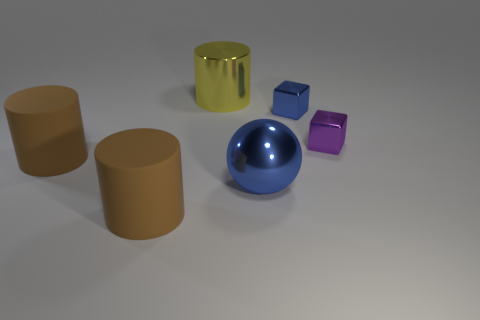Subtract all yellow cylinders. How many cylinders are left? 2 Subtract all gray cubes. How many brown cylinders are left? 2 Add 1 large brown cylinders. How many objects exist? 7 Subtract all cubes. How many objects are left? 4 Subtract all big brown things. Subtract all big blue metal balls. How many objects are left? 3 Add 3 small metal objects. How many small metal objects are left? 5 Add 5 balls. How many balls exist? 6 Subtract 1 blue balls. How many objects are left? 5 